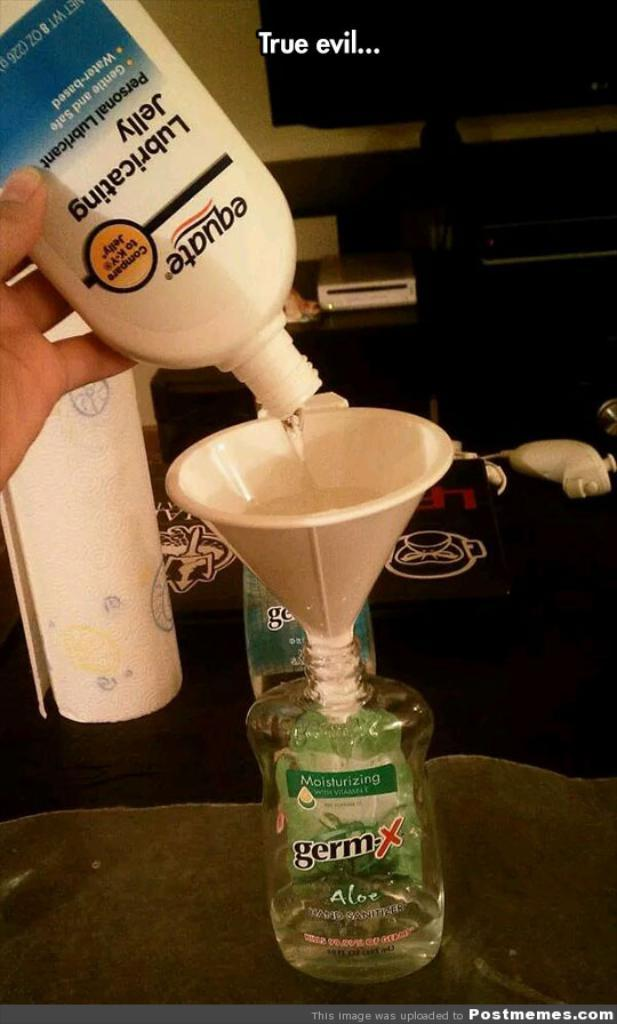<image>
Write a terse but informative summary of the picture. A bottle of liquid reading Germ having something funnelled into it. 